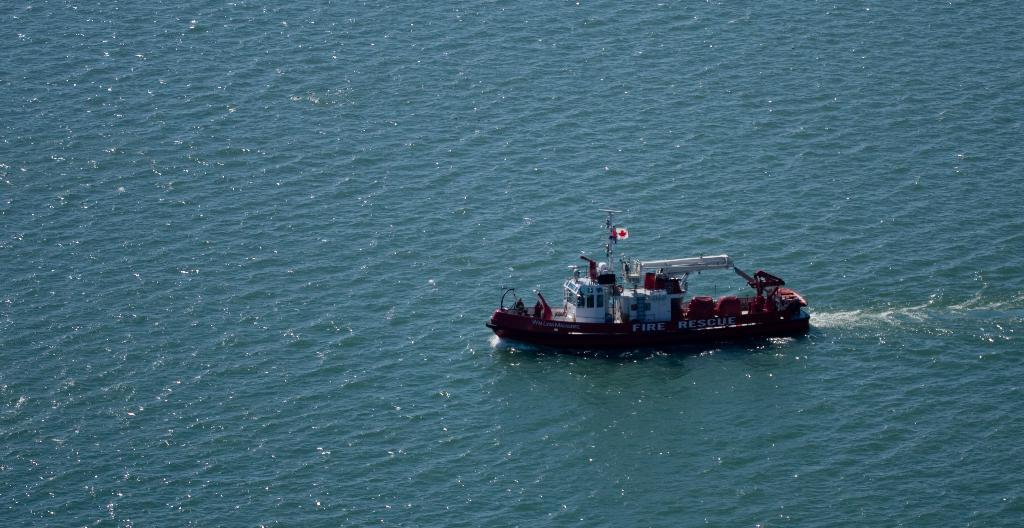What is the main subject of the image? There is a boat in the image. What is the boat's position in relation to the water? The boat is above the water. In which direction is the boat facing? The boat is facing towards the left side of the image. What scientific discovery is being made on the boat in the image? There is no indication of a scientific discovery being made on the boat in the image. How many times has the boat been involved in a war in the image? There is no mention of war or any conflict in the image, so it cannot be determined how many times the boat has been involved in a war. 